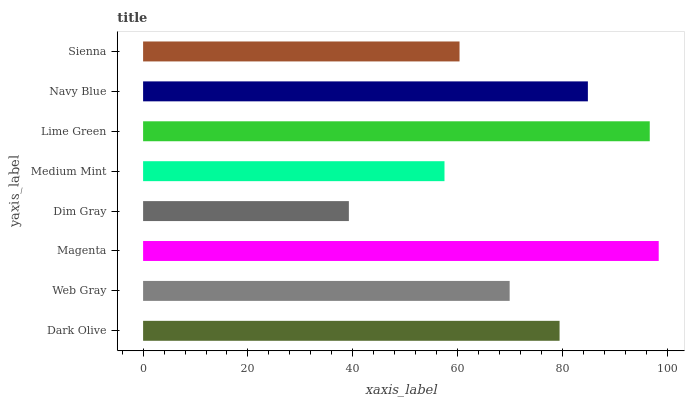Is Dim Gray the minimum?
Answer yes or no. Yes. Is Magenta the maximum?
Answer yes or no. Yes. Is Web Gray the minimum?
Answer yes or no. No. Is Web Gray the maximum?
Answer yes or no. No. Is Dark Olive greater than Web Gray?
Answer yes or no. Yes. Is Web Gray less than Dark Olive?
Answer yes or no. Yes. Is Web Gray greater than Dark Olive?
Answer yes or no. No. Is Dark Olive less than Web Gray?
Answer yes or no. No. Is Dark Olive the high median?
Answer yes or no. Yes. Is Web Gray the low median?
Answer yes or no. Yes. Is Sienna the high median?
Answer yes or no. No. Is Medium Mint the low median?
Answer yes or no. No. 